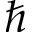Convert formula to latex. <formula><loc_0><loc_0><loc_500><loc_500>\hbar</formula> 